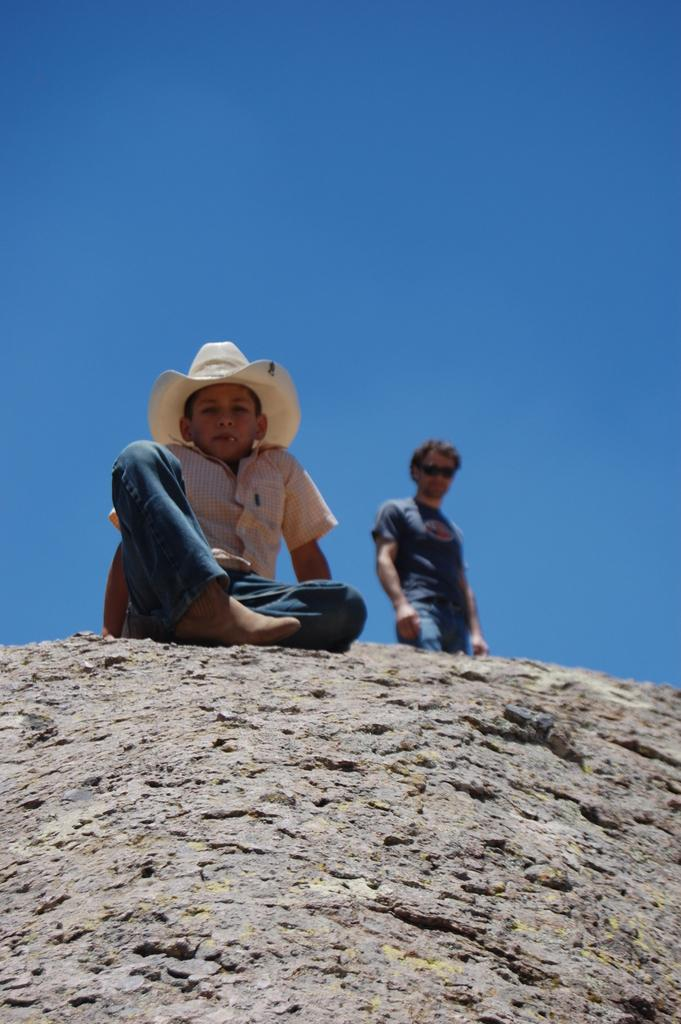What is the primary subject of the image? There is a person standing in the image. What is the secondary subject of the image? There is a kid sitting in the image. What is the kid wearing on their head? The kid is wearing a cap. What can be seen in the background of the image? The sky is visible at the top of the image. What type of ink can be seen on the person's shirt in the image? There is no ink visible on the person's shirt in the image. Are there any pets present in the image? There is no mention of pets in the provided facts, so we cannot determine if any are present in the image. 